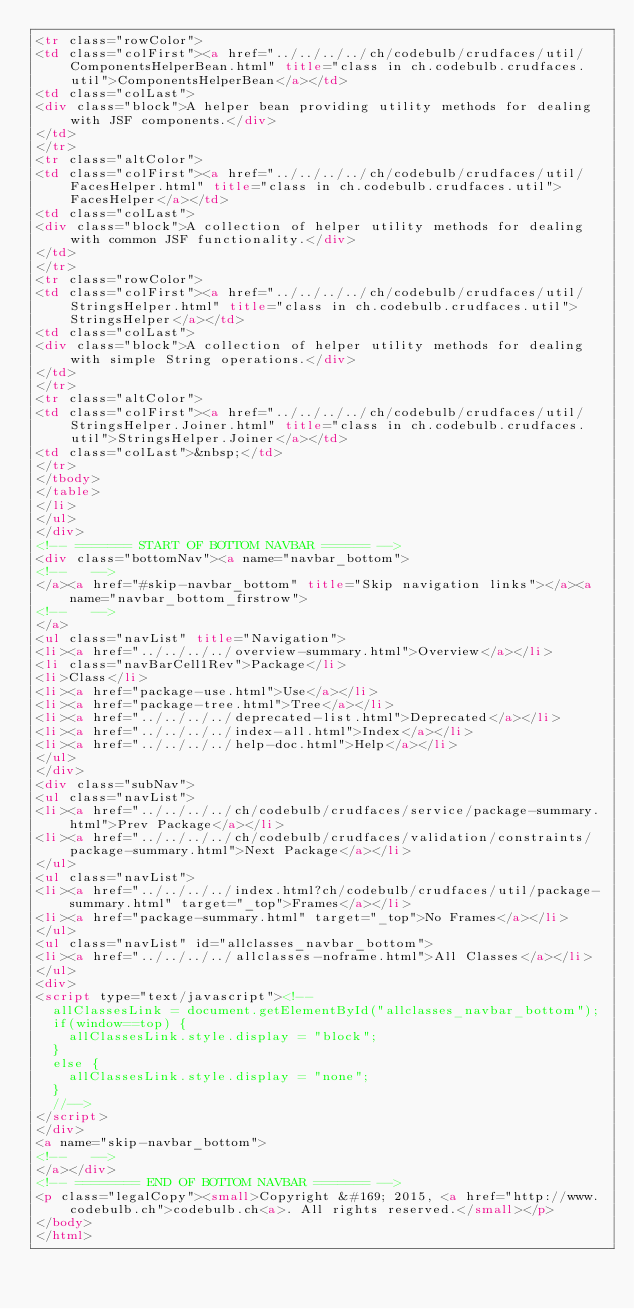<code> <loc_0><loc_0><loc_500><loc_500><_HTML_><tr class="rowColor">
<td class="colFirst"><a href="../../../../ch/codebulb/crudfaces/util/ComponentsHelperBean.html" title="class in ch.codebulb.crudfaces.util">ComponentsHelperBean</a></td>
<td class="colLast">
<div class="block">A helper bean providing utility methods for dealing with JSF components.</div>
</td>
</tr>
<tr class="altColor">
<td class="colFirst"><a href="../../../../ch/codebulb/crudfaces/util/FacesHelper.html" title="class in ch.codebulb.crudfaces.util">FacesHelper</a></td>
<td class="colLast">
<div class="block">A collection of helper utility methods for dealing with common JSF functionality.</div>
</td>
</tr>
<tr class="rowColor">
<td class="colFirst"><a href="../../../../ch/codebulb/crudfaces/util/StringsHelper.html" title="class in ch.codebulb.crudfaces.util">StringsHelper</a></td>
<td class="colLast">
<div class="block">A collection of helper utility methods for dealing with simple String operations.</div>
</td>
</tr>
<tr class="altColor">
<td class="colFirst"><a href="../../../../ch/codebulb/crudfaces/util/StringsHelper.Joiner.html" title="class in ch.codebulb.crudfaces.util">StringsHelper.Joiner</a></td>
<td class="colLast">&nbsp;</td>
</tr>
</tbody>
</table>
</li>
</ul>
</div>
<!-- ======= START OF BOTTOM NAVBAR ====== -->
<div class="bottomNav"><a name="navbar_bottom">
<!--   -->
</a><a href="#skip-navbar_bottom" title="Skip navigation links"></a><a name="navbar_bottom_firstrow">
<!--   -->
</a>
<ul class="navList" title="Navigation">
<li><a href="../../../../overview-summary.html">Overview</a></li>
<li class="navBarCell1Rev">Package</li>
<li>Class</li>
<li><a href="package-use.html">Use</a></li>
<li><a href="package-tree.html">Tree</a></li>
<li><a href="../../../../deprecated-list.html">Deprecated</a></li>
<li><a href="../../../../index-all.html">Index</a></li>
<li><a href="../../../../help-doc.html">Help</a></li>
</ul>
</div>
<div class="subNav">
<ul class="navList">
<li><a href="../../../../ch/codebulb/crudfaces/service/package-summary.html">Prev Package</a></li>
<li><a href="../../../../ch/codebulb/crudfaces/validation/constraints/package-summary.html">Next Package</a></li>
</ul>
<ul class="navList">
<li><a href="../../../../index.html?ch/codebulb/crudfaces/util/package-summary.html" target="_top">Frames</a></li>
<li><a href="package-summary.html" target="_top">No Frames</a></li>
</ul>
<ul class="navList" id="allclasses_navbar_bottom">
<li><a href="../../../../allclasses-noframe.html">All Classes</a></li>
</ul>
<div>
<script type="text/javascript"><!--
  allClassesLink = document.getElementById("allclasses_navbar_bottom");
  if(window==top) {
    allClassesLink.style.display = "block";
  }
  else {
    allClassesLink.style.display = "none";
  }
  //-->
</script>
</div>
<a name="skip-navbar_bottom">
<!--   -->
</a></div>
<!-- ======== END OF BOTTOM NAVBAR ======= -->
<p class="legalCopy"><small>Copyright &#169; 2015, <a href="http://www.codebulb.ch">codebulb.ch<a>. All rights reserved.</small></p>
</body>
</html>
</code> 